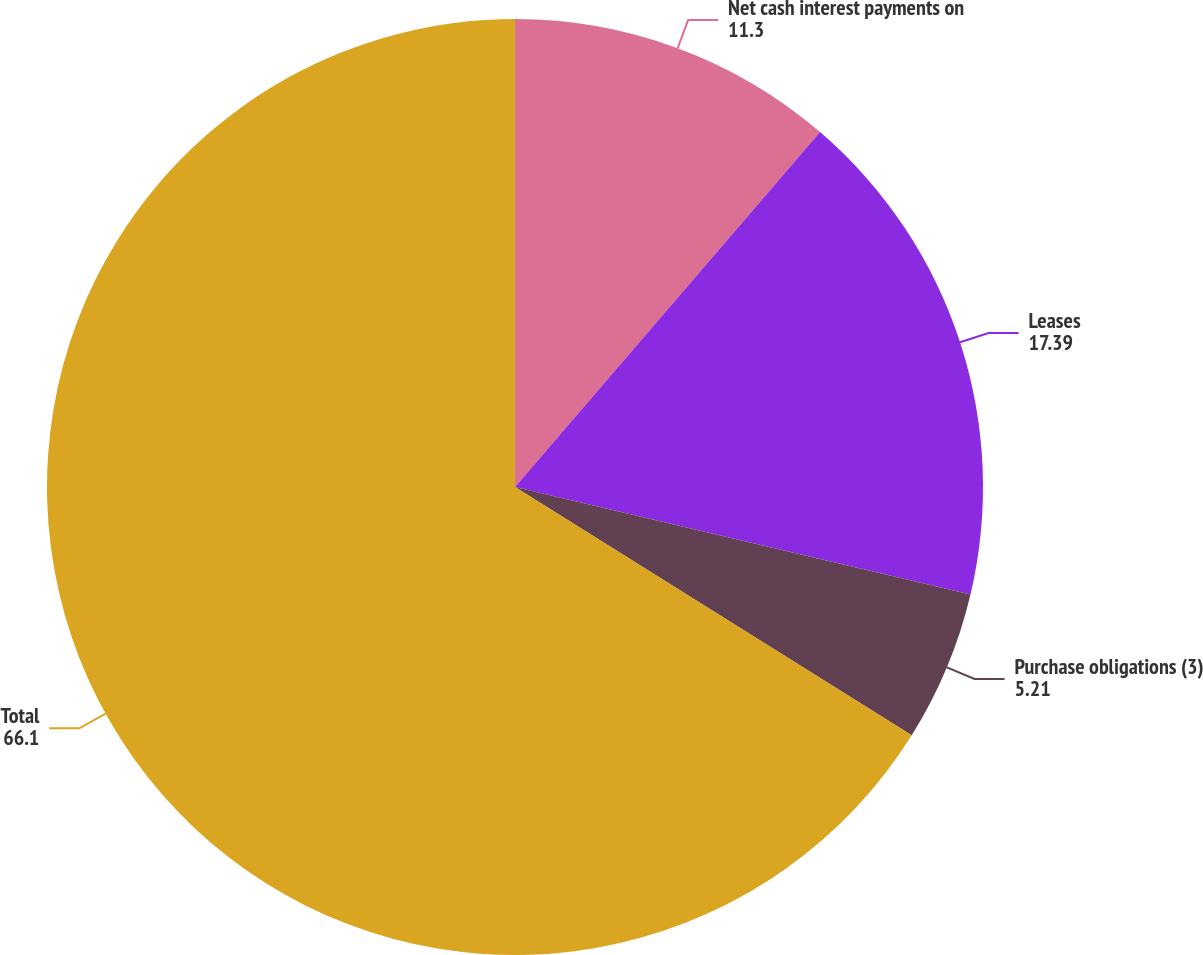Convert chart to OTSL. <chart><loc_0><loc_0><loc_500><loc_500><pie_chart><fcel>Net cash interest payments on<fcel>Leases<fcel>Purchase obligations (3)<fcel>Total<nl><fcel>11.3%<fcel>17.39%<fcel>5.21%<fcel>66.1%<nl></chart> 